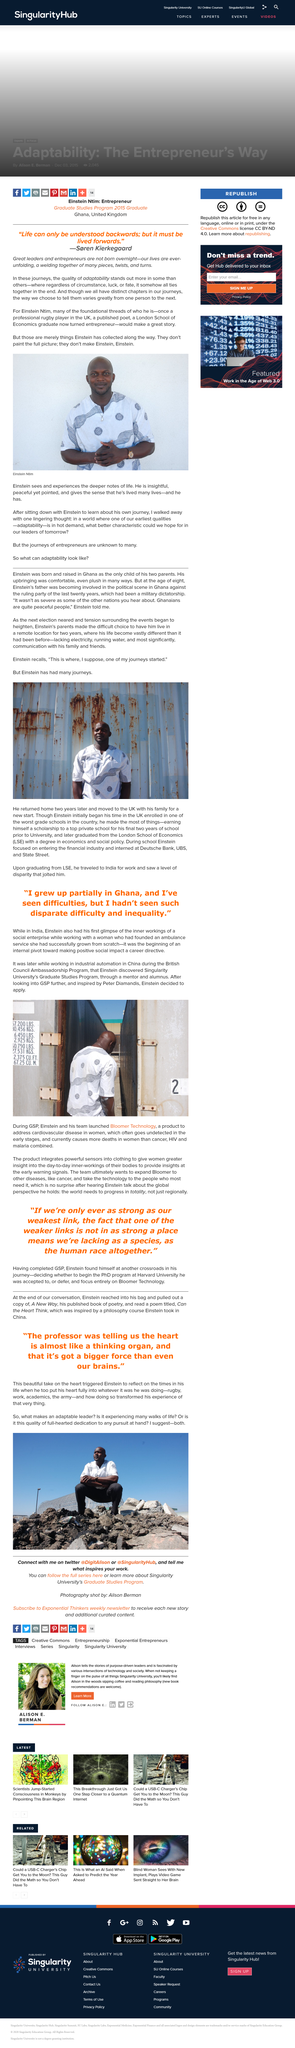Point out several critical features in this image. Albert Einstein attended the London School of Economics. Albert Einstein read a poem that was inspired by a philosophy course he took in China, which was titled "Can the Heart Think?". Einstein discovered his passion for social entrepreneurship in India, but it was in China where he fully embraced the social business model. The person who is featured in the photo at the bottom of the page is Einstein Ntim. Einstein pulled out of his bag at the end of the conversation a book that was his published book of poetry, A New Way of Thinking. 